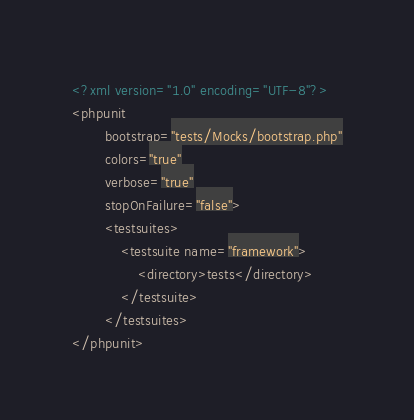<code> <loc_0><loc_0><loc_500><loc_500><_XML_><?xml version="1.0" encoding="UTF-8"?>
<phpunit
        bootstrap="tests/Mocks/bootstrap.php"
        colors="true"
        verbose="true"
        stopOnFailure="false">
        <testsuites>
            <testsuite name="framework">
                <directory>tests</directory>
            </testsuite>
        </testsuites>
</phpunit></code> 